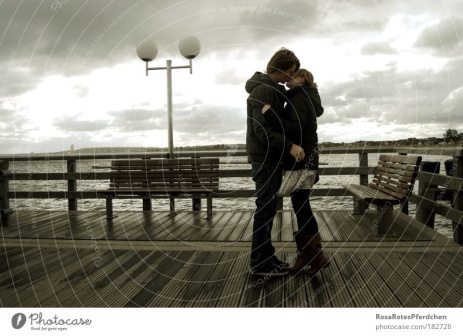Could you suggest a story behind this photograph? Imagine this couple celebrating a significant anniversary, perhaps revisiting the pier where they first met or shared a meaningful moment early in their relationship. The overcast sky and their gentle embrace suggest a moment of reflection and deep emotional connection, as they reminisce about their shared journey. They might be thinking about the challenges they've overcome together and the future that lies ahead, symbolized by the endless horizon stretching before them on this timeless pier. 